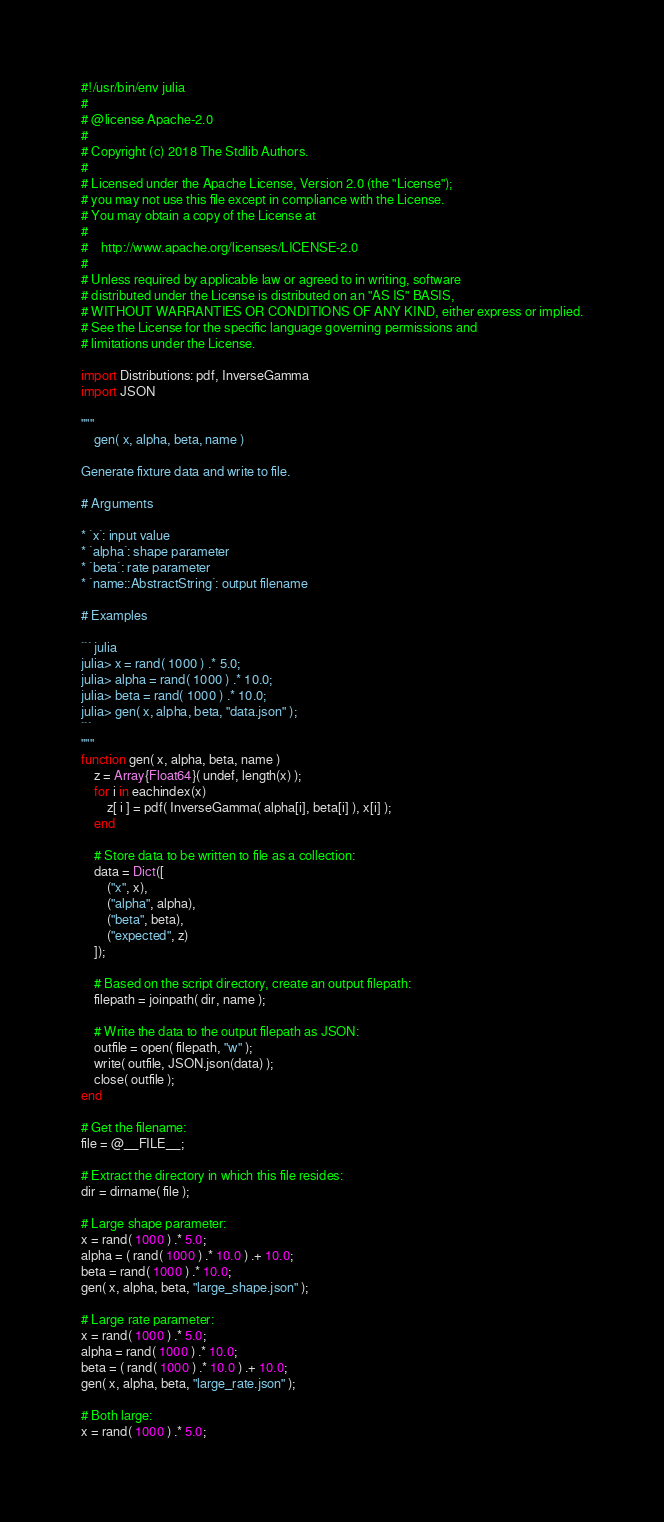Convert code to text. <code><loc_0><loc_0><loc_500><loc_500><_Julia_>#!/usr/bin/env julia
#
# @license Apache-2.0
#
# Copyright (c) 2018 The Stdlib Authors.
#
# Licensed under the Apache License, Version 2.0 (the "License");
# you may not use this file except in compliance with the License.
# You may obtain a copy of the License at
#
#    http://www.apache.org/licenses/LICENSE-2.0
#
# Unless required by applicable law or agreed to in writing, software
# distributed under the License is distributed on an "AS IS" BASIS,
# WITHOUT WARRANTIES OR CONDITIONS OF ANY KIND, either express or implied.
# See the License for the specific language governing permissions and
# limitations under the License.

import Distributions: pdf, InverseGamma
import JSON

"""
	gen( x, alpha, beta, name )

Generate fixture data and write to file.

# Arguments

* `x`: input value
* `alpha`: shape parameter
* `beta`: rate parameter
* `name::AbstractString`: output filename

# Examples

``` julia
julia> x = rand( 1000 ) .* 5.0;
julia> alpha = rand( 1000 ) .* 10.0;
julia> beta = rand( 1000 ) .* 10.0;
julia> gen( x, alpha, beta, "data.json" );
```
"""
function gen( x, alpha, beta, name )
	z = Array{Float64}( undef, length(x) );
	for i in eachindex(x)
		z[ i ] = pdf( InverseGamma( alpha[i], beta[i] ), x[i] );
	end

	# Store data to be written to file as a collection:
	data = Dict([
		("x", x),
		("alpha", alpha),
		("beta", beta),
		("expected", z)
	]);

	# Based on the script directory, create an output filepath:
	filepath = joinpath( dir, name );

	# Write the data to the output filepath as JSON:
	outfile = open( filepath, "w" );
	write( outfile, JSON.json(data) );
	close( outfile );
end

# Get the filename:
file = @__FILE__;

# Extract the directory in which this file resides:
dir = dirname( file );

# Large shape parameter:
x = rand( 1000 ) .* 5.0;
alpha = ( rand( 1000 ) .* 10.0 ) .+ 10.0;
beta = rand( 1000 ) .* 10.0;
gen( x, alpha, beta, "large_shape.json" );

# Large rate parameter:
x = rand( 1000 ) .* 5.0;
alpha = rand( 1000 ) .* 10.0;
beta = ( rand( 1000 ) .* 10.0 ) .+ 10.0;
gen( x, alpha, beta, "large_rate.json" );

# Both large:
x = rand( 1000 ) .* 5.0;</code> 